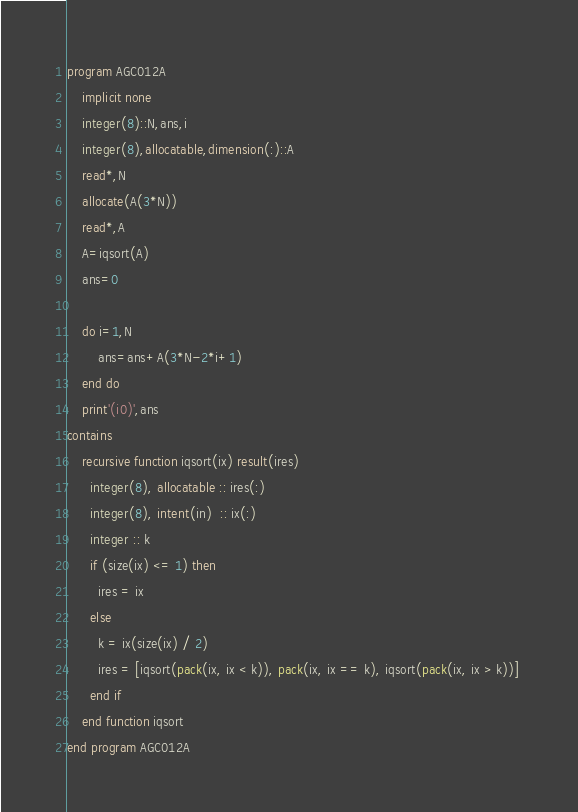<code> <loc_0><loc_0><loc_500><loc_500><_FORTRAN_>program AGC012A
    implicit none
    integer(8)::N,ans,i
    integer(8),allocatable,dimension(:)::A
    read*,N
    allocate(A(3*N))
    read*,A
    A=iqsort(A)
    ans=0

    do i=1,N
        ans=ans+A(3*N-2*i+1)
    end do
    print'(i0)',ans
contains
    recursive function iqsort(ix) result(ires)
      integer(8), allocatable :: ires(:)
      integer(8), intent(in)  :: ix(:)
      integer :: k
      if (size(ix) <= 1) then 
        ires = ix
      else  
        k = ix(size(ix) / 2)
        ires = [iqsort(pack(ix, ix < k)), pack(ix, ix == k), iqsort(pack(ix, ix > k))] 
      end if
    end function iqsort
end program AGC012A</code> 